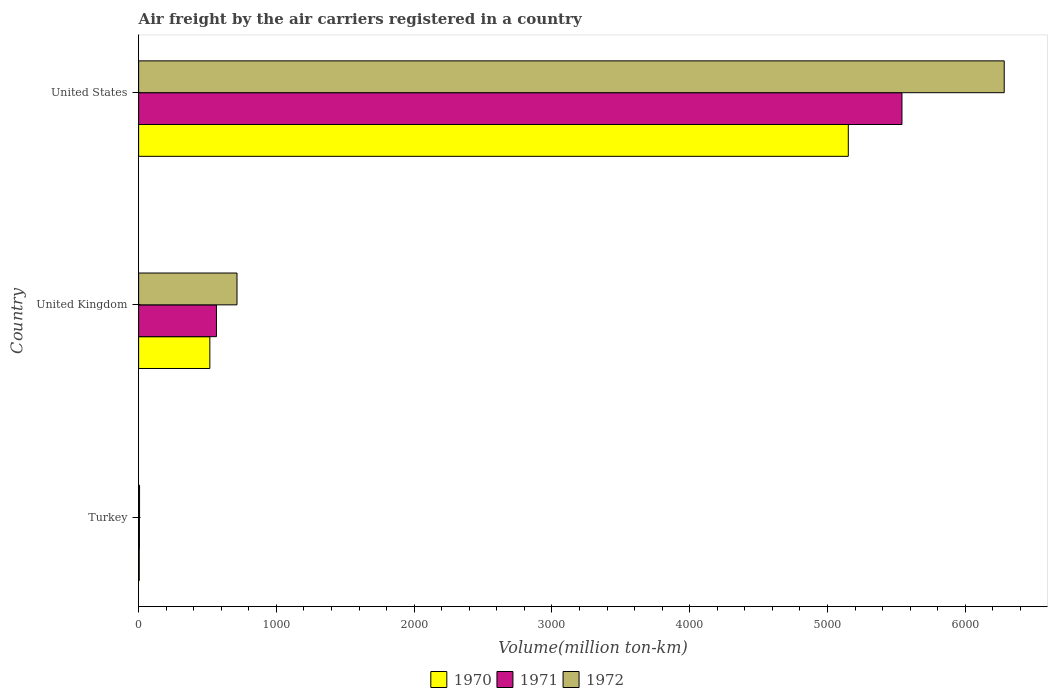How many different coloured bars are there?
Keep it short and to the point. 3. Are the number of bars on each tick of the Y-axis equal?
Offer a very short reply. Yes. How many bars are there on the 1st tick from the top?
Provide a succinct answer. 3. What is the label of the 3rd group of bars from the top?
Ensure brevity in your answer.  Turkey. In how many cases, is the number of bars for a given country not equal to the number of legend labels?
Your response must be concise. 0. What is the volume of the air carriers in 1970 in Turkey?
Offer a terse response. 4.6. Across all countries, what is the maximum volume of the air carriers in 1972?
Offer a terse response. 6283. Across all countries, what is the minimum volume of the air carriers in 1971?
Your answer should be very brief. 5.7. What is the total volume of the air carriers in 1972 in the graph?
Keep it short and to the point. 7003.9. What is the difference between the volume of the air carriers in 1972 in Turkey and that in United States?
Make the answer very short. -6276.2. What is the difference between the volume of the air carriers in 1971 in United States and the volume of the air carriers in 1972 in Turkey?
Offer a very short reply. 5534. What is the average volume of the air carriers in 1972 per country?
Your response must be concise. 2334.63. What is the difference between the volume of the air carriers in 1971 and volume of the air carriers in 1970 in Turkey?
Offer a terse response. 1.1. What is the ratio of the volume of the air carriers in 1971 in Turkey to that in United Kingdom?
Ensure brevity in your answer.  0.01. Is the difference between the volume of the air carriers in 1971 in Turkey and United Kingdom greater than the difference between the volume of the air carriers in 1970 in Turkey and United Kingdom?
Provide a short and direct response. No. What is the difference between the highest and the second highest volume of the air carriers in 1971?
Provide a short and direct response. 4975.9. What is the difference between the highest and the lowest volume of the air carriers in 1971?
Ensure brevity in your answer.  5535.1. Is the sum of the volume of the air carriers in 1971 in Turkey and United States greater than the maximum volume of the air carriers in 1970 across all countries?
Provide a succinct answer. Yes. How many bars are there?
Your answer should be compact. 9. Are all the bars in the graph horizontal?
Your answer should be compact. Yes. Does the graph contain any zero values?
Provide a succinct answer. No. How many legend labels are there?
Your answer should be very brief. 3. What is the title of the graph?
Ensure brevity in your answer.  Air freight by the air carriers registered in a country. What is the label or title of the X-axis?
Your response must be concise. Volume(million ton-km). What is the Volume(million ton-km) of 1970 in Turkey?
Offer a terse response. 4.6. What is the Volume(million ton-km) in 1971 in Turkey?
Provide a short and direct response. 5.7. What is the Volume(million ton-km) in 1972 in Turkey?
Your response must be concise. 6.8. What is the Volume(million ton-km) in 1970 in United Kingdom?
Your answer should be compact. 516.9. What is the Volume(million ton-km) in 1971 in United Kingdom?
Offer a very short reply. 564.9. What is the Volume(million ton-km) in 1972 in United Kingdom?
Ensure brevity in your answer.  714.1. What is the Volume(million ton-km) in 1970 in United States?
Ensure brevity in your answer.  5151.2. What is the Volume(million ton-km) in 1971 in United States?
Provide a succinct answer. 5540.8. What is the Volume(million ton-km) in 1972 in United States?
Your answer should be compact. 6283. Across all countries, what is the maximum Volume(million ton-km) of 1970?
Give a very brief answer. 5151.2. Across all countries, what is the maximum Volume(million ton-km) in 1971?
Give a very brief answer. 5540.8. Across all countries, what is the maximum Volume(million ton-km) of 1972?
Offer a terse response. 6283. Across all countries, what is the minimum Volume(million ton-km) of 1970?
Make the answer very short. 4.6. Across all countries, what is the minimum Volume(million ton-km) in 1971?
Keep it short and to the point. 5.7. Across all countries, what is the minimum Volume(million ton-km) of 1972?
Provide a short and direct response. 6.8. What is the total Volume(million ton-km) in 1970 in the graph?
Make the answer very short. 5672.7. What is the total Volume(million ton-km) in 1971 in the graph?
Your answer should be compact. 6111.4. What is the total Volume(million ton-km) in 1972 in the graph?
Provide a short and direct response. 7003.9. What is the difference between the Volume(million ton-km) of 1970 in Turkey and that in United Kingdom?
Offer a very short reply. -512.3. What is the difference between the Volume(million ton-km) of 1971 in Turkey and that in United Kingdom?
Provide a short and direct response. -559.2. What is the difference between the Volume(million ton-km) in 1972 in Turkey and that in United Kingdom?
Keep it short and to the point. -707.3. What is the difference between the Volume(million ton-km) in 1970 in Turkey and that in United States?
Ensure brevity in your answer.  -5146.6. What is the difference between the Volume(million ton-km) of 1971 in Turkey and that in United States?
Give a very brief answer. -5535.1. What is the difference between the Volume(million ton-km) of 1972 in Turkey and that in United States?
Make the answer very short. -6276.2. What is the difference between the Volume(million ton-km) of 1970 in United Kingdom and that in United States?
Provide a succinct answer. -4634.3. What is the difference between the Volume(million ton-km) of 1971 in United Kingdom and that in United States?
Provide a succinct answer. -4975.9. What is the difference between the Volume(million ton-km) of 1972 in United Kingdom and that in United States?
Provide a succinct answer. -5568.9. What is the difference between the Volume(million ton-km) in 1970 in Turkey and the Volume(million ton-km) in 1971 in United Kingdom?
Your answer should be compact. -560.3. What is the difference between the Volume(million ton-km) of 1970 in Turkey and the Volume(million ton-km) of 1972 in United Kingdom?
Your answer should be compact. -709.5. What is the difference between the Volume(million ton-km) of 1971 in Turkey and the Volume(million ton-km) of 1972 in United Kingdom?
Your answer should be compact. -708.4. What is the difference between the Volume(million ton-km) in 1970 in Turkey and the Volume(million ton-km) in 1971 in United States?
Your answer should be very brief. -5536.2. What is the difference between the Volume(million ton-km) in 1970 in Turkey and the Volume(million ton-km) in 1972 in United States?
Give a very brief answer. -6278.4. What is the difference between the Volume(million ton-km) of 1971 in Turkey and the Volume(million ton-km) of 1972 in United States?
Provide a short and direct response. -6277.3. What is the difference between the Volume(million ton-km) of 1970 in United Kingdom and the Volume(million ton-km) of 1971 in United States?
Your response must be concise. -5023.9. What is the difference between the Volume(million ton-km) of 1970 in United Kingdom and the Volume(million ton-km) of 1972 in United States?
Keep it short and to the point. -5766.1. What is the difference between the Volume(million ton-km) in 1971 in United Kingdom and the Volume(million ton-km) in 1972 in United States?
Ensure brevity in your answer.  -5718.1. What is the average Volume(million ton-km) of 1970 per country?
Your answer should be very brief. 1890.9. What is the average Volume(million ton-km) in 1971 per country?
Keep it short and to the point. 2037.13. What is the average Volume(million ton-km) in 1972 per country?
Provide a succinct answer. 2334.63. What is the difference between the Volume(million ton-km) in 1970 and Volume(million ton-km) in 1972 in Turkey?
Ensure brevity in your answer.  -2.2. What is the difference between the Volume(million ton-km) of 1970 and Volume(million ton-km) of 1971 in United Kingdom?
Provide a short and direct response. -48. What is the difference between the Volume(million ton-km) of 1970 and Volume(million ton-km) of 1972 in United Kingdom?
Give a very brief answer. -197.2. What is the difference between the Volume(million ton-km) in 1971 and Volume(million ton-km) in 1972 in United Kingdom?
Provide a short and direct response. -149.2. What is the difference between the Volume(million ton-km) in 1970 and Volume(million ton-km) in 1971 in United States?
Your answer should be compact. -389.6. What is the difference between the Volume(million ton-km) in 1970 and Volume(million ton-km) in 1972 in United States?
Offer a very short reply. -1131.8. What is the difference between the Volume(million ton-km) of 1971 and Volume(million ton-km) of 1972 in United States?
Offer a very short reply. -742.2. What is the ratio of the Volume(million ton-km) of 1970 in Turkey to that in United Kingdom?
Give a very brief answer. 0.01. What is the ratio of the Volume(million ton-km) of 1971 in Turkey to that in United Kingdom?
Your response must be concise. 0.01. What is the ratio of the Volume(million ton-km) of 1972 in Turkey to that in United Kingdom?
Your response must be concise. 0.01. What is the ratio of the Volume(million ton-km) of 1970 in Turkey to that in United States?
Your answer should be very brief. 0. What is the ratio of the Volume(million ton-km) in 1971 in Turkey to that in United States?
Your answer should be compact. 0. What is the ratio of the Volume(million ton-km) of 1972 in Turkey to that in United States?
Your response must be concise. 0. What is the ratio of the Volume(million ton-km) of 1970 in United Kingdom to that in United States?
Provide a short and direct response. 0.1. What is the ratio of the Volume(million ton-km) of 1971 in United Kingdom to that in United States?
Ensure brevity in your answer.  0.1. What is the ratio of the Volume(million ton-km) of 1972 in United Kingdom to that in United States?
Your response must be concise. 0.11. What is the difference between the highest and the second highest Volume(million ton-km) in 1970?
Give a very brief answer. 4634.3. What is the difference between the highest and the second highest Volume(million ton-km) in 1971?
Give a very brief answer. 4975.9. What is the difference between the highest and the second highest Volume(million ton-km) in 1972?
Give a very brief answer. 5568.9. What is the difference between the highest and the lowest Volume(million ton-km) in 1970?
Keep it short and to the point. 5146.6. What is the difference between the highest and the lowest Volume(million ton-km) in 1971?
Provide a succinct answer. 5535.1. What is the difference between the highest and the lowest Volume(million ton-km) in 1972?
Provide a short and direct response. 6276.2. 